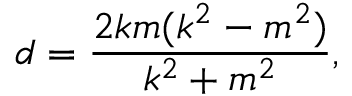<formula> <loc_0><loc_0><loc_500><loc_500>d = { \frac { 2 k m ( k ^ { 2 } - m ^ { 2 } ) } { k ^ { 2 } + m ^ { 2 } } } ,</formula> 